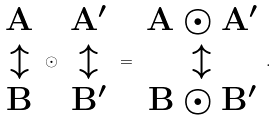Convert formula to latex. <formula><loc_0><loc_0><loc_500><loc_500>\begin{array} { c } \mathbf A \\ \updownarrow \\ \mathbf B \end{array} \odot \begin{array} { c } \mathbf A ^ { \prime } \\ \updownarrow \\ \mathbf B ^ { \prime } \end{array} = \begin{array} { c } \mathbf A \odot \mathbf A ^ { \prime } \\ \updownarrow \\ \mathbf B \odot \mathbf B ^ { \prime } \end{array} .</formula> 